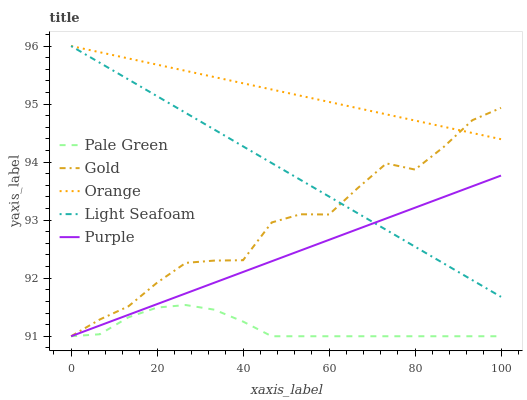Does Pale Green have the minimum area under the curve?
Answer yes or no. Yes. Does Orange have the maximum area under the curve?
Answer yes or no. Yes. Does Purple have the minimum area under the curve?
Answer yes or no. No. Does Purple have the maximum area under the curve?
Answer yes or no. No. Is Purple the smoothest?
Answer yes or no. Yes. Is Gold the roughest?
Answer yes or no. Yes. Is Pale Green the smoothest?
Answer yes or no. No. Is Pale Green the roughest?
Answer yes or no. No. Does Light Seafoam have the lowest value?
Answer yes or no. No. Does Light Seafoam have the highest value?
Answer yes or no. Yes. Does Purple have the highest value?
Answer yes or no. No. Is Pale Green less than Light Seafoam?
Answer yes or no. Yes. Is Orange greater than Pale Green?
Answer yes or no. Yes. Does Light Seafoam intersect Gold?
Answer yes or no. Yes. Is Light Seafoam less than Gold?
Answer yes or no. No. Is Light Seafoam greater than Gold?
Answer yes or no. No. Does Pale Green intersect Light Seafoam?
Answer yes or no. No. 